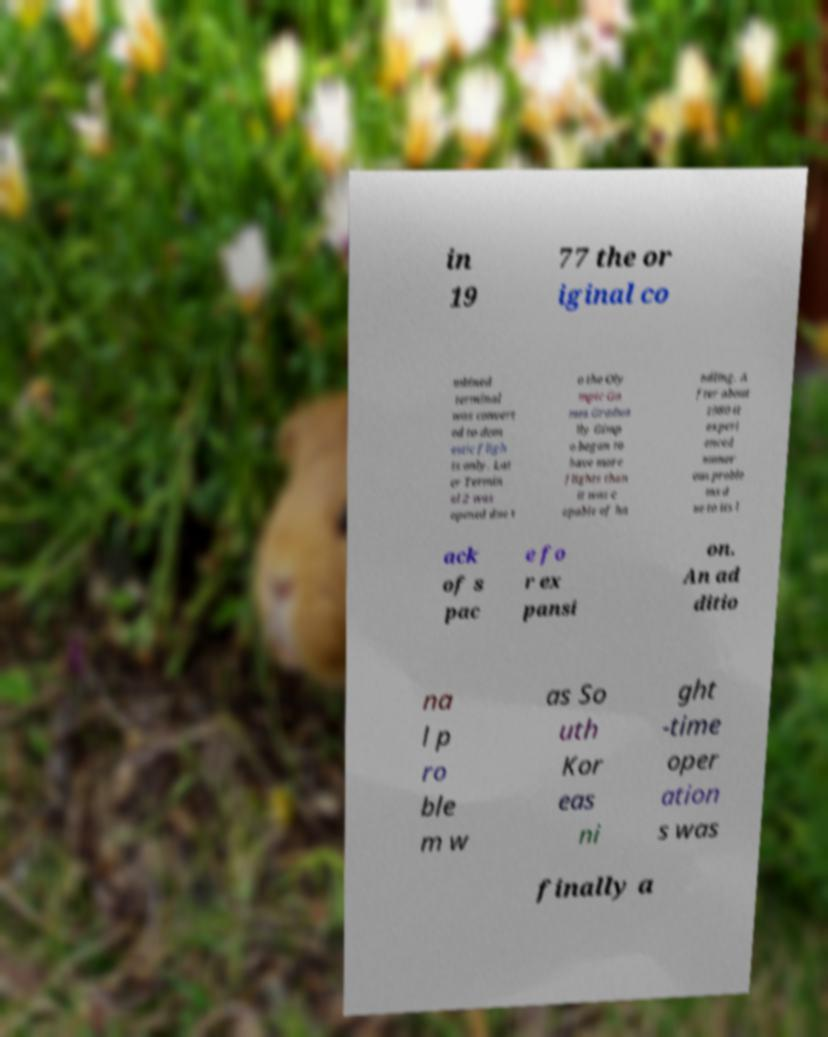Please identify and transcribe the text found in this image. in 19 77 the or iginal co mbined terminal was convert ed to dom estic fligh ts only. Lat er Termin al 2 was opened due t o the Oly mpic Ga mes.Gradua lly Gimp o began to have more flights than it was c apable of ha ndling. A fter about 1980 it experi enced numer ous proble ms d ue to its l ack of s pac e fo r ex pansi on. An ad ditio na l p ro ble m w as So uth Kor eas ni ght -time oper ation s was finally a 